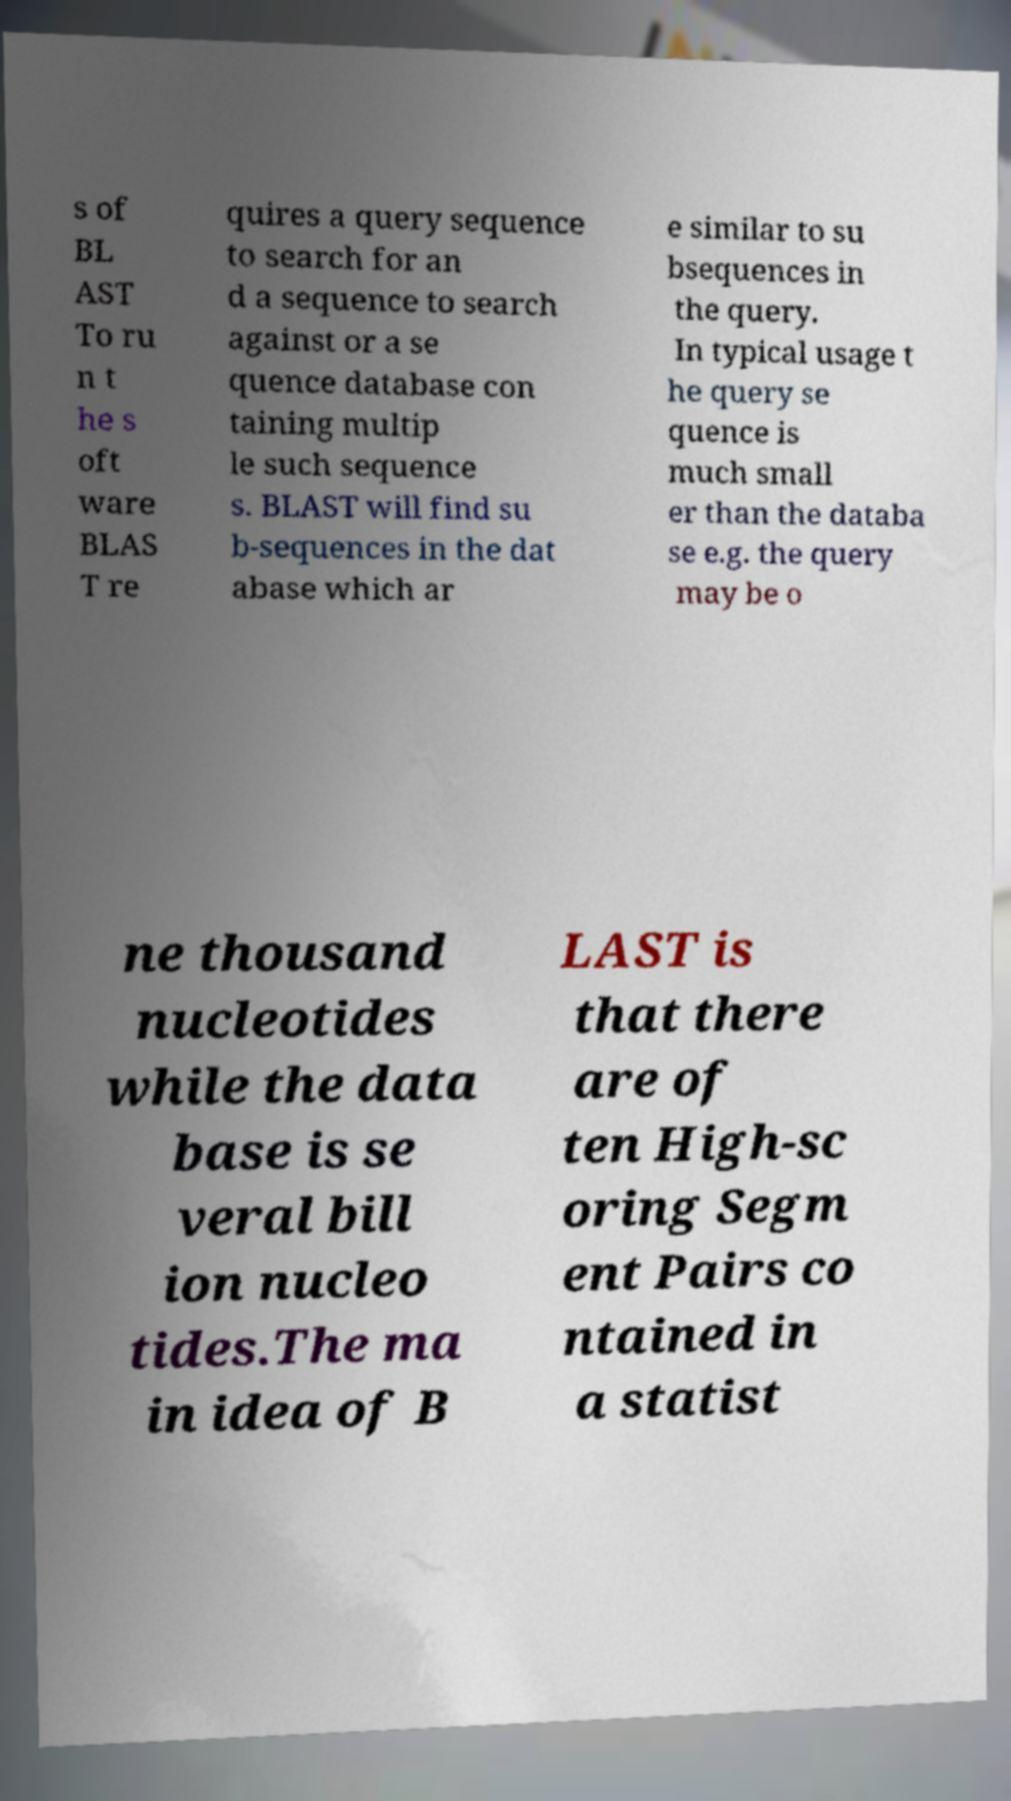What messages or text are displayed in this image? I need them in a readable, typed format. s of BL AST To ru n t he s oft ware BLAS T re quires a query sequence to search for an d a sequence to search against or a se quence database con taining multip le such sequence s. BLAST will find su b-sequences in the dat abase which ar e similar to su bsequences in the query. In typical usage t he query se quence is much small er than the databa se e.g. the query may be o ne thousand nucleotides while the data base is se veral bill ion nucleo tides.The ma in idea of B LAST is that there are of ten High-sc oring Segm ent Pairs co ntained in a statist 